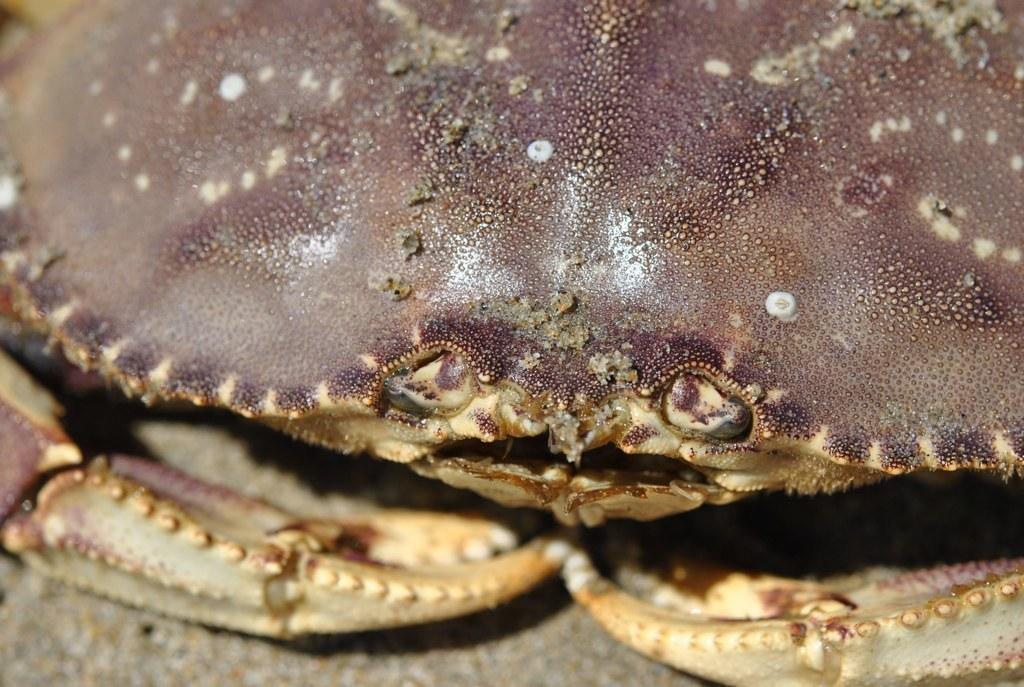Could you give a brief overview of what you see in this image? In this picture I can see a crab. 